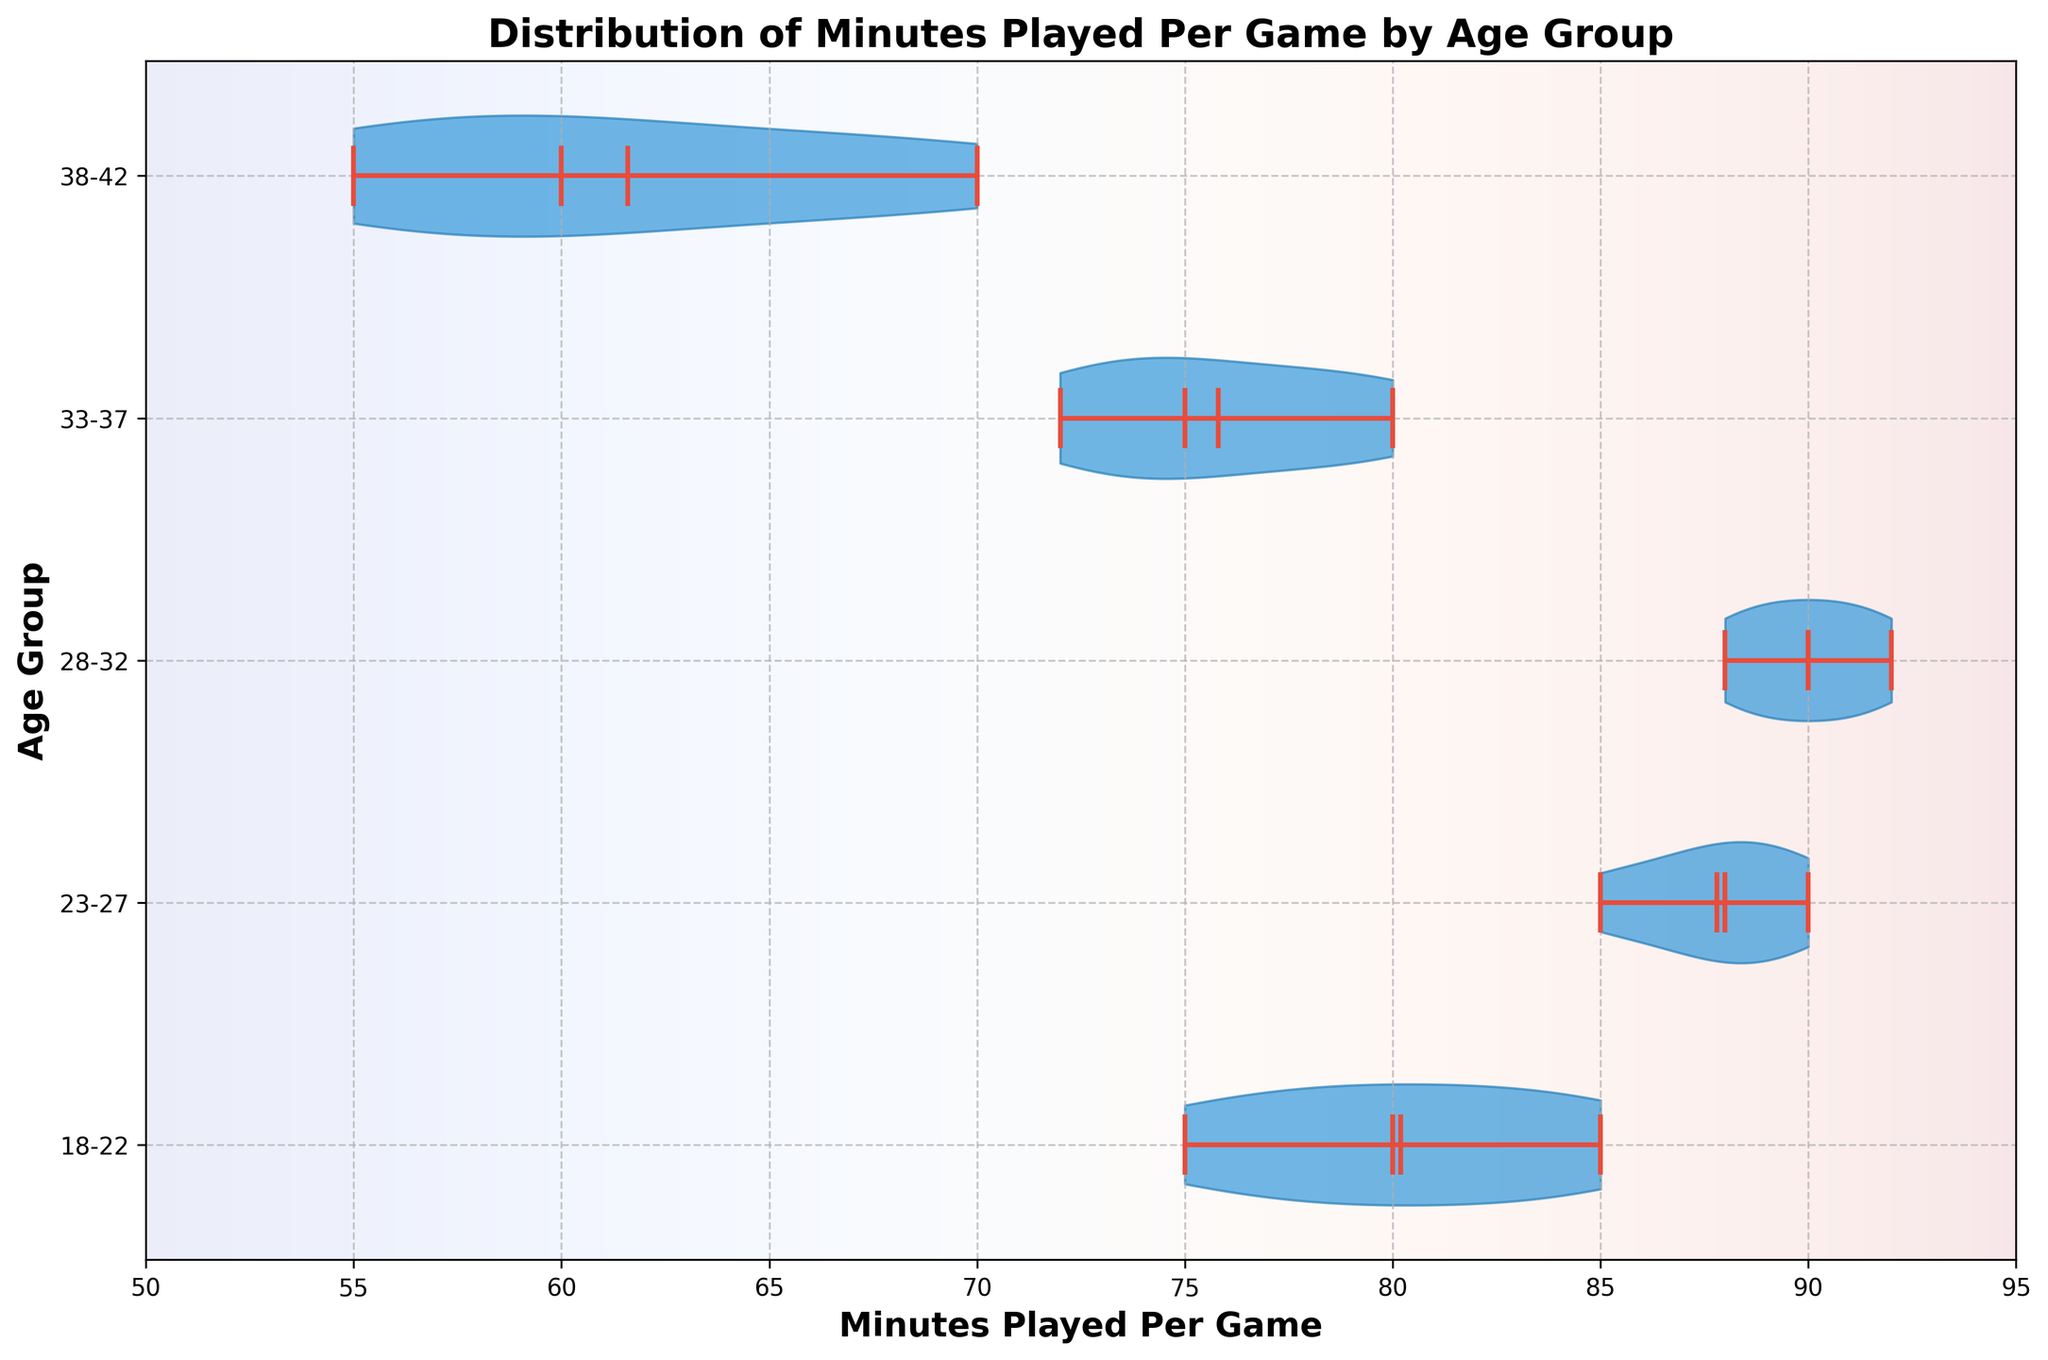What is the title of the plot? The title is located at the top of the plot and describes the overall content. In this case, it should mention the distribution of minutes played per game by age group.
Answer: Distribution of Minutes Played Per Game by Age Group Which age group has the highest median Minutes Played Per Game? From the violin plot, the median is marked by a central line within each violin plot. By looking at the central lines for each age group, the 28-32 age group has the highest median.
Answer: 28-32 What is the range of minutes played for the 33-37 age group? The range is the difference between the maximum and minimum values shown for the group. For the 33-37 age group, it's observed that the range is from 72 to 80 minutes.
Answer: 72 to 80 minutes How does the spread of minutes played for the 18-22 age group compare to the 38-42 age group? The spread or distribution can be seen by the width and length of the violin plot. The 18-22 age group has a wider and more spread out distribution compared to the narrower 38-42 age group's distribution.
Answer: 18-22 is wider and more spread out than 38-42 What is the mean Minutes Played Per Game for the 23-27 age group? The mean value is shown by a white dot within each violin plot. By referring to the plot, the mean value for the 23-27 age group can be determined.
Answer: Approximately 87 minutes Which age group has the narrowest distribution of Minutes Played Per Game? The narrowest distribution is visible as the thinnest violin plot. By comparing all groups, the 38-42 age group has the narrowest distribution.
Answer: 38-42 Are there any age groups with an outlier in minutes played? Outliers would be shown as points outside the main area of the violin plot. By observing the plot, no age groups seem to have outliers.
Answer: No How much higher is the maximum Minutes Played Per Game for the 28-32 age group compared to the 38-42 age group? The maximum value for the 28-32 age group is 92 minutes and for the 38-42 age group is 70 minutes. The difference is 92 - 70 = 22 minutes.
Answer: 22 minutes Which age group has the largest interquartile range (IQR) for Minutes Played Per Game? The IQR is represented by the width of the central, thicker part of the violin plot. The 18-22 age group has the largest interquartile range since its middle part is the widest.
Answer: 18-22 